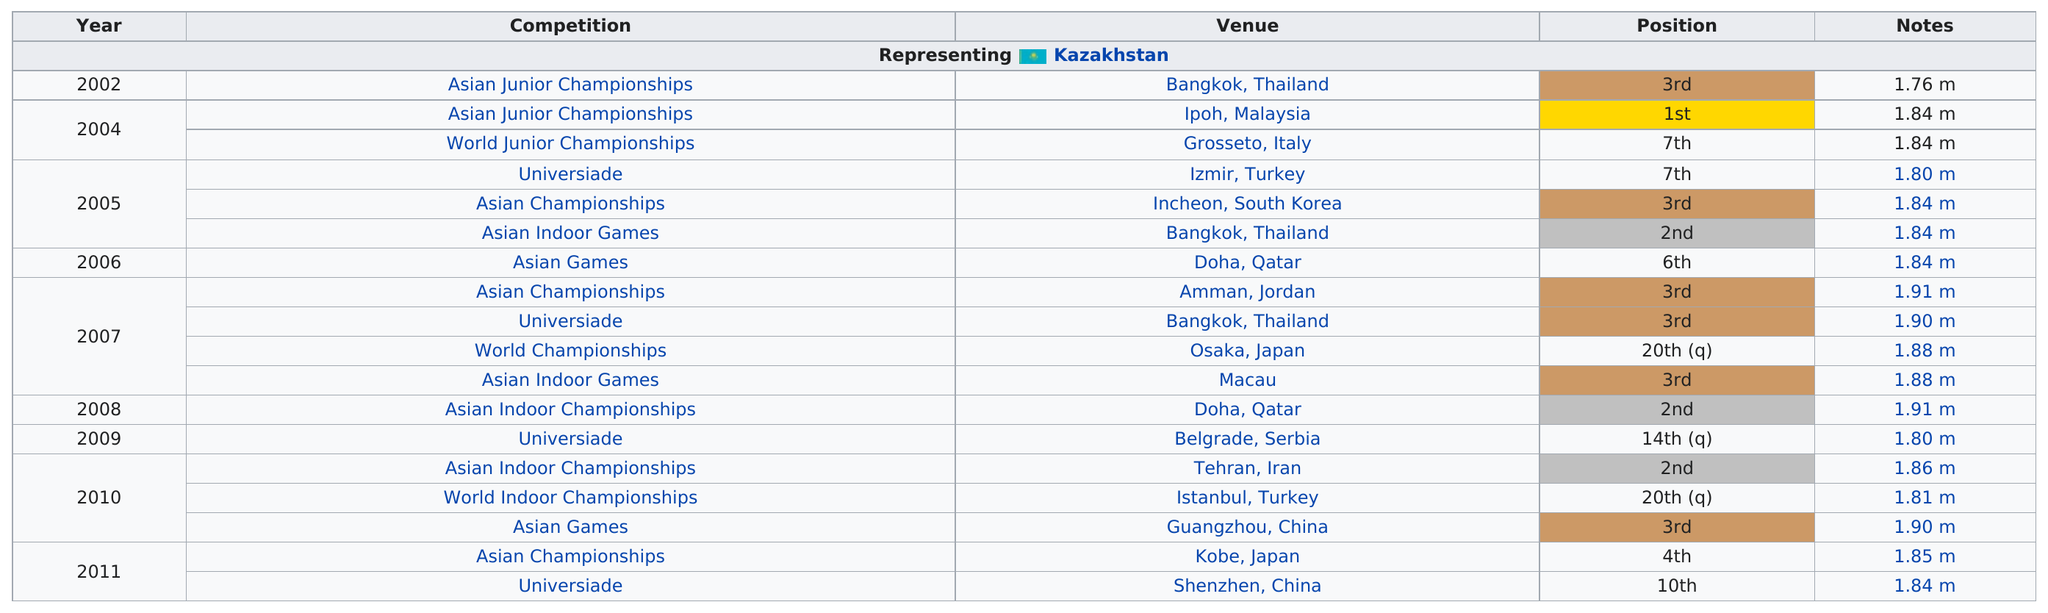Point out several critical features in this image. Anna Ustinova came in third a total of six times. In 2010, a total of 3 competitions were held. Anna Ustinova had been competing for two years before she won first place. The Asian Junior Championships was the first competition featured on the chart. Anna Ustinova took 6th place at the only venue where she competed, which was Doha, Qatar. 